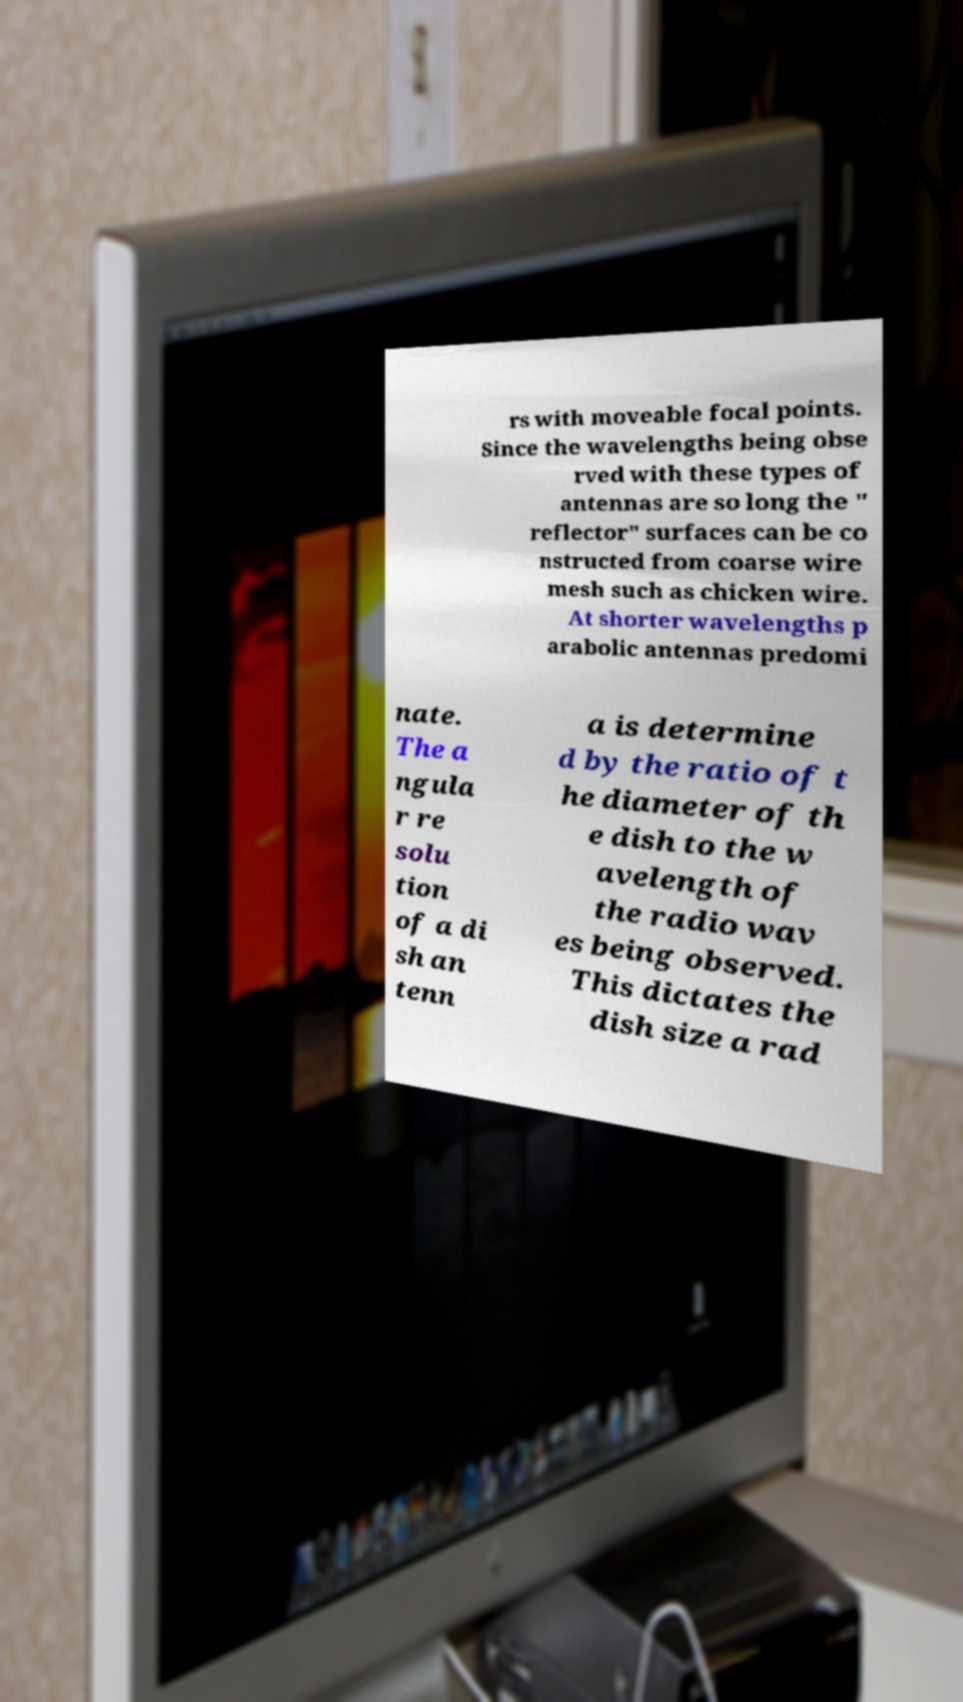There's text embedded in this image that I need extracted. Can you transcribe it verbatim? rs with moveable focal points. Since the wavelengths being obse rved with these types of antennas are so long the " reflector" surfaces can be co nstructed from coarse wire mesh such as chicken wire. At shorter wavelengths p arabolic antennas predomi nate. The a ngula r re solu tion of a di sh an tenn a is determine d by the ratio of t he diameter of th e dish to the w avelength of the radio wav es being observed. This dictates the dish size a rad 